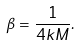Convert formula to latex. <formula><loc_0><loc_0><loc_500><loc_500>\beta = \frac { 1 } { 4 k M } .</formula> 